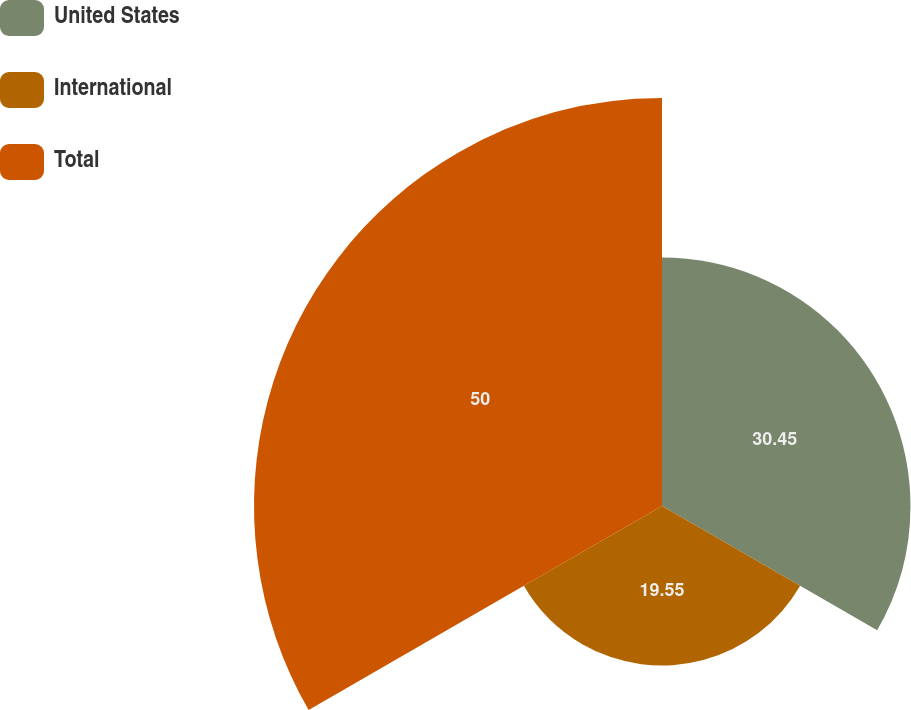<chart> <loc_0><loc_0><loc_500><loc_500><pie_chart><fcel>United States<fcel>International<fcel>Total<nl><fcel>30.45%<fcel>19.55%<fcel>50.0%<nl></chart> 